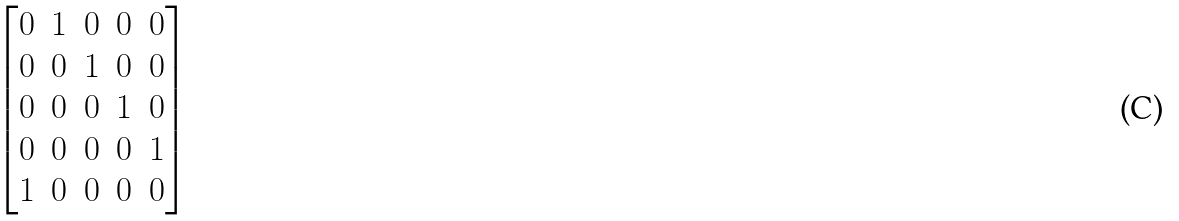<formula> <loc_0><loc_0><loc_500><loc_500>\begin{bmatrix} 0 & 1 & 0 & 0 & 0 \\ 0 & 0 & 1 & 0 & 0 \\ 0 & 0 & 0 & 1 & 0 \\ 0 & 0 & 0 & 0 & 1 \\ 1 & 0 & 0 & 0 & 0 \end{bmatrix}</formula> 